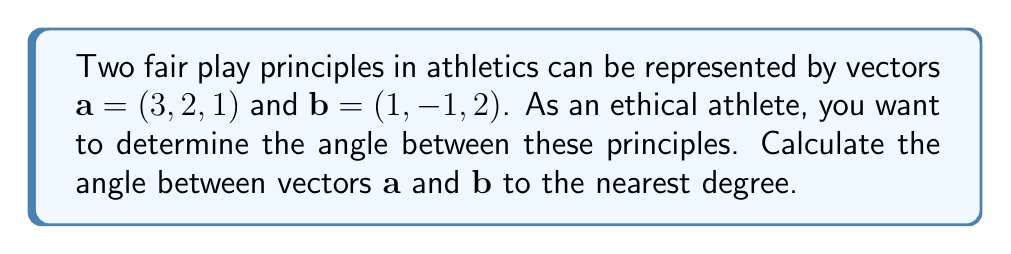Help me with this question. To find the angle between two vectors, we can use the dot product formula:

$$\cos \theta = \frac{\mathbf{a} \cdot \mathbf{b}}{|\mathbf{a}||\mathbf{b}|}$$

Step 1: Calculate the dot product $\mathbf{a} \cdot \mathbf{b}$
$$\mathbf{a} \cdot \mathbf{b} = (3)(1) + (2)(-1) + (1)(2) = 3 - 2 + 2 = 3$$

Step 2: Calculate the magnitudes of vectors $\mathbf{a}$ and $\mathbf{b}$
$$|\mathbf{a}| = \sqrt{3^2 + 2^2 + 1^2} = \sqrt{14}$$
$$|\mathbf{b}| = \sqrt{1^2 + (-1)^2 + 2^2} = \sqrt{6}$$

Step 3: Substitute into the formula
$$\cos \theta = \frac{3}{\sqrt{14}\sqrt{6}}$$

Step 4: Solve for $\theta$
$$\theta = \arccos\left(\frac{3}{\sqrt{14}\sqrt{6}}\right)$$

Step 5: Calculate and round to the nearest degree
$$\theta \approx 70.5^\circ \approx 71^\circ$$
Answer: $71^\circ$ 